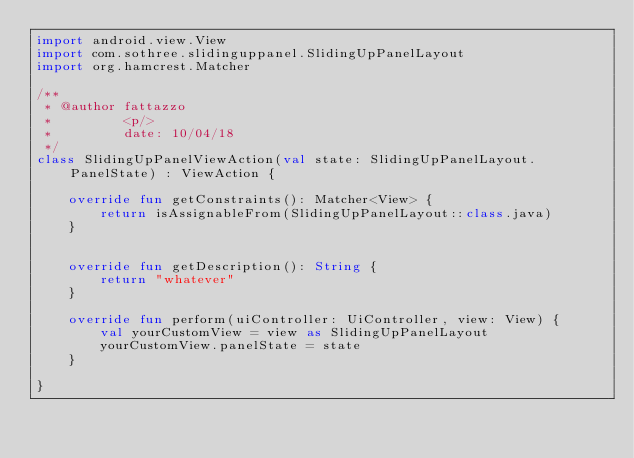<code> <loc_0><loc_0><loc_500><loc_500><_Kotlin_>import android.view.View
import com.sothree.slidinguppanel.SlidingUpPanelLayout
import org.hamcrest.Matcher

/**
 * @author fattazzo
 *         <p/>
 *         date: 10/04/18
 */
class SlidingUpPanelViewAction(val state: SlidingUpPanelLayout.PanelState) : ViewAction {

    override fun getConstraints(): Matcher<View> {
        return isAssignableFrom(SlidingUpPanelLayout::class.java)
    }


    override fun getDescription(): String {
        return "whatever"
    }

    override fun perform(uiController: UiController, view: View) {
        val yourCustomView = view as SlidingUpPanelLayout
        yourCustomView.panelState = state
    }

}</code> 